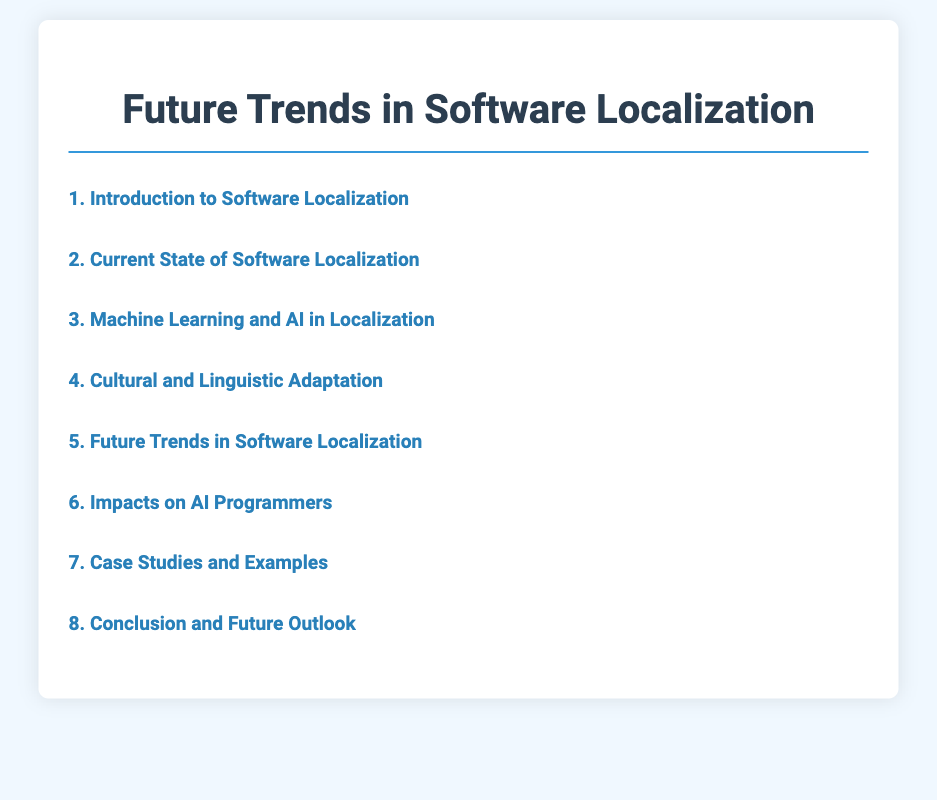what is the title of the document? The title is presented as the main heading at the top of the document.
Answer: Future Trends in Software Localization what section discusses AI in localization? The section focusing on AI is specifically named within the table of contents.
Answer: Machine Learning and AI in Localization how many subsections are under "Future Trends in Software Localization"? The number of subsections is listed directly under the corresponding main section title.
Answer: Five what is the last subsection listed in the document? The last subsection appears at the end of the corresponding section in the table of contents.
Answer: Predictions for the Next Decade which major companies are mentioned in the case studies section? The companies referenced in the case studies section are highlighted in the list of subsections.
Answer: Major Companies which element signifies the conclusion of the document? The conclusion section is specifically identified in the table of contents.
Answer: Conclusion and Future Outlook what is the focus of subsection 5.2? The focus is explicitly stated in the title of the subsection within the main section.
Answer: Real-time Localization and Adaptation which section covers ethical considerations in automated localization? The section concerning ethical considerations is clearly mentioned in the table of contents.
Answer: Impacts on AI Programmers 